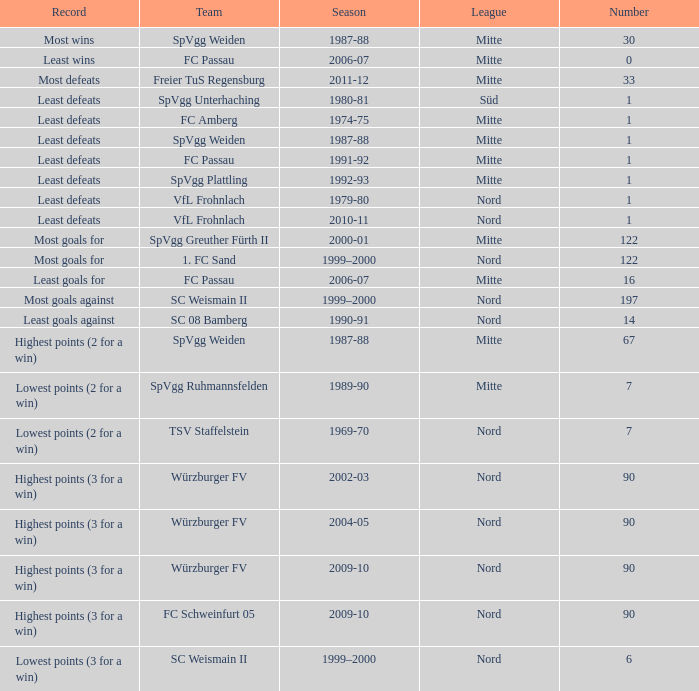Which league, numbered less than 122, has the record for the smallest amount of wins? Mitte. 